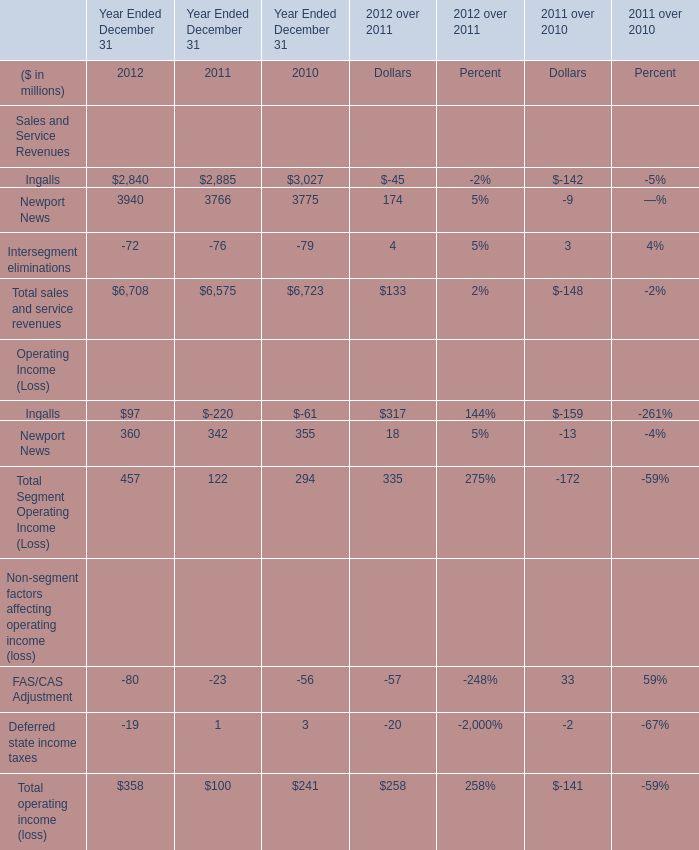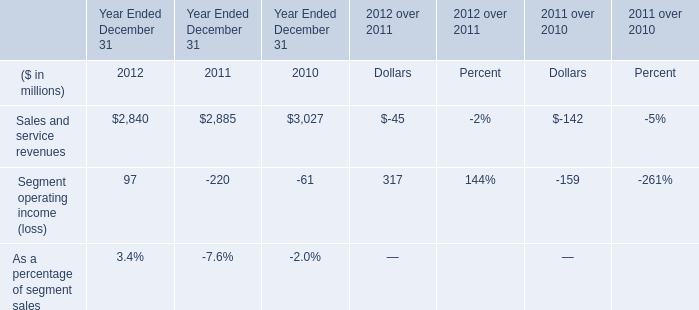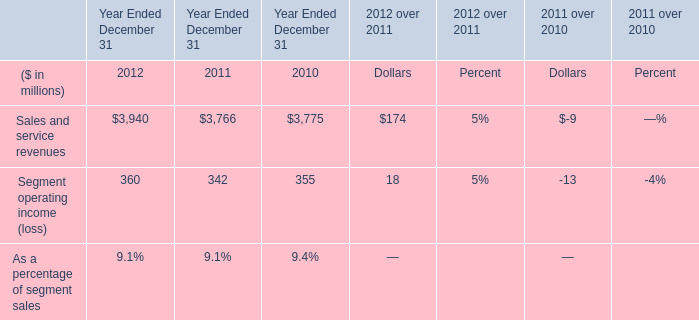What's the current increasing rate of Total sales and service revenues? (in %) 
Computations: ((6708 - 6575) / 6575)
Answer: 0.02023. 